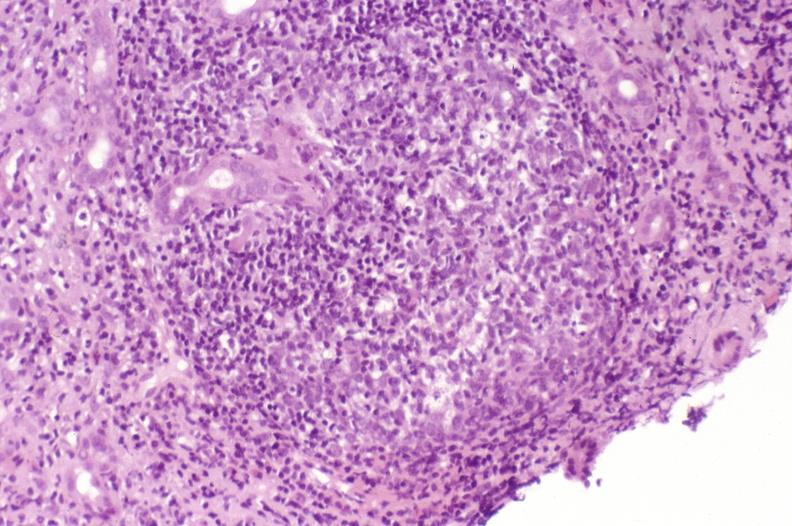what is present?
Answer the question using a single word or phrase. Liver 